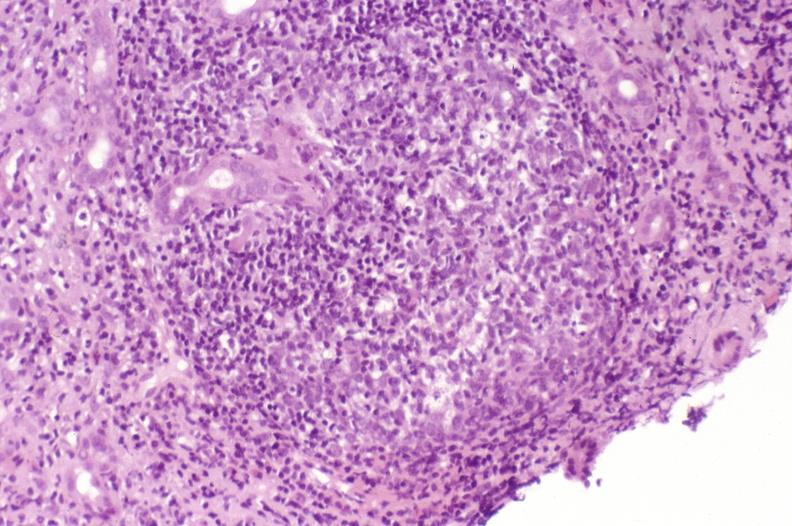what is present?
Answer the question using a single word or phrase. Liver 